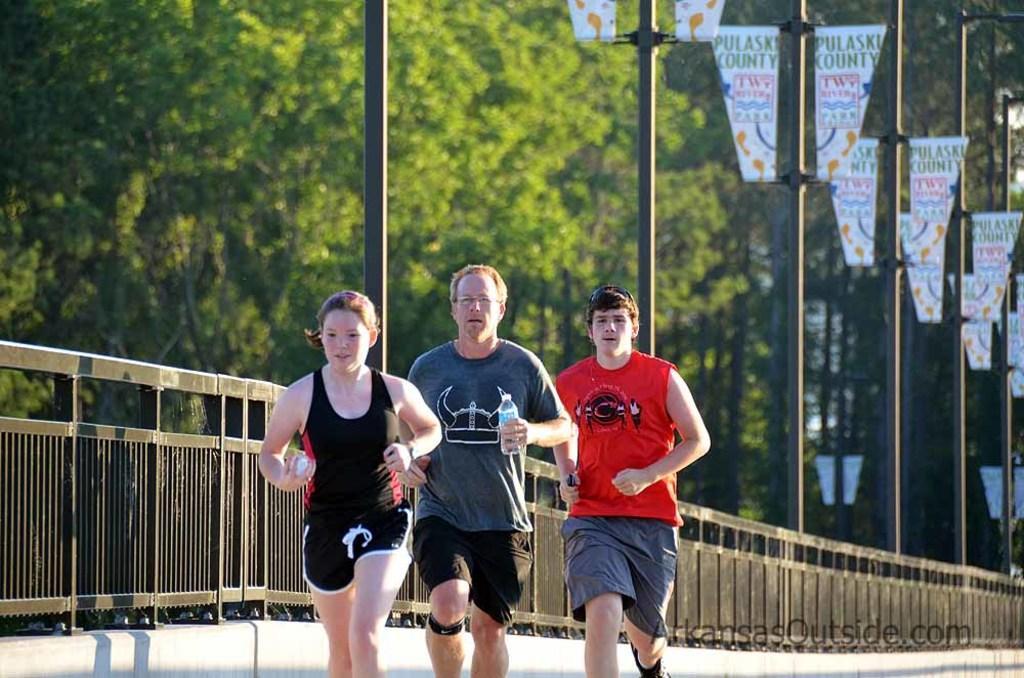Could you give a brief overview of what you see in this image? In the center of the image we can see three people running. The man standing in the center is holding a bottle in his hand. On the left there is a fence and there are poles. We can see boards. In the background there are trees. 